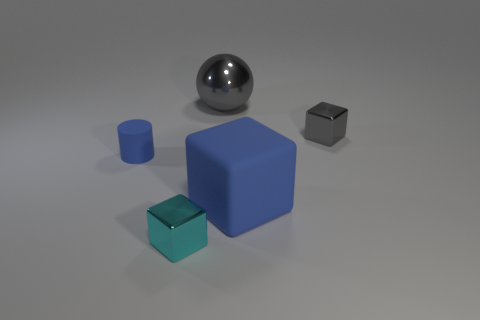The metal object that is on the right side of the big blue rubber thing is what color?
Your response must be concise. Gray. Are there fewer big gray metallic objects that are to the right of the gray shiny sphere than big red cylinders?
Your answer should be compact. No. Is the blue cylinder made of the same material as the blue block?
Offer a very short reply. Yes. What size is the matte thing that is the same shape as the cyan metallic thing?
Your answer should be compact. Large. How many objects are objects in front of the large gray metal sphere or gray metal things in front of the metal sphere?
Offer a terse response. 4. Are there fewer blue blocks than big objects?
Keep it short and to the point. Yes. There is a gray metal block; is its size the same as the gray object that is on the left side of the small gray object?
Make the answer very short. No. What number of matte things are tiny cyan objects or blue things?
Offer a very short reply. 2. Are there more things than tiny blue cubes?
Your answer should be compact. Yes. There is a object that is the same color as the cylinder; what is its size?
Make the answer very short. Large. 